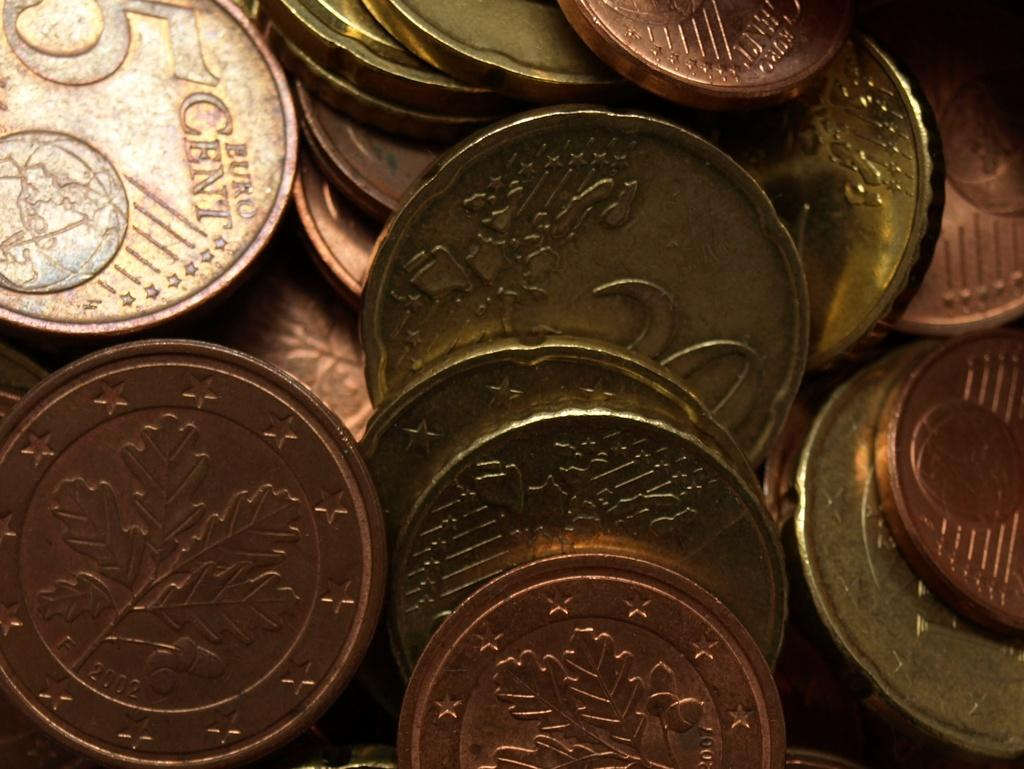What objects can be seen in the image? There are coins in the image. Can you describe the appearance of the coins? The coins appear to be round and metallic. How many coins are visible in the image? The number of coins cannot be determined from the image alone. What type of instrument is being played in the image? There is no instrument present in the image; it only contains coins. 